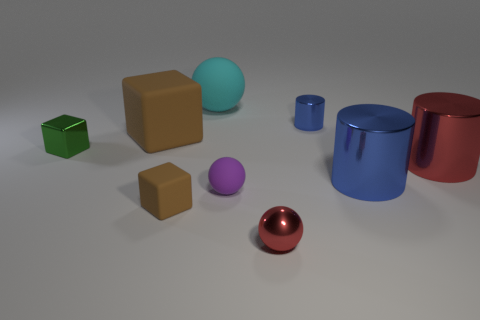What is the sphere that is behind the small rubber cube and right of the cyan matte sphere made of?
Provide a short and direct response. Rubber. There is a rubber block that is behind the red metallic cylinder; is its size the same as the tiny purple sphere?
Ensure brevity in your answer.  No. What shape is the large cyan rubber thing?
Keep it short and to the point. Sphere. How many blue things have the same shape as the large red object?
Your answer should be compact. 2. What number of objects are both behind the small matte cube and in front of the large cyan rubber thing?
Give a very brief answer. 6. The small metallic sphere has what color?
Your answer should be very brief. Red. Is there a yellow cylinder that has the same material as the large block?
Your answer should be very brief. No. There is a small blue thing behind the red metal object that is left of the tiny metallic cylinder; are there any small brown cubes that are on the right side of it?
Your answer should be compact. No. Are there any tiny objects to the left of the cyan matte ball?
Offer a very short reply. Yes. Are there any large objects that have the same color as the small rubber block?
Keep it short and to the point. Yes. 